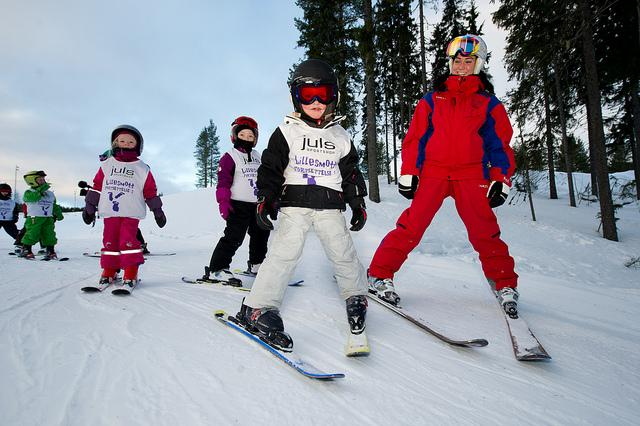Which person is the teacher? Please explain your reasoning. red clothes. The person in red is tallest. 